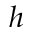Convert formula to latex. <formula><loc_0><loc_0><loc_500><loc_500>h</formula> 